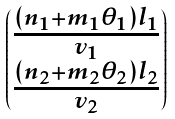Convert formula to latex. <formula><loc_0><loc_0><loc_500><loc_500>\begin{pmatrix} \frac { ( n _ { 1 } + m _ { 1 } \theta _ { 1 } ) l _ { 1 } } { v _ { 1 } } \\ \frac { ( n _ { 2 } + m _ { 2 } \theta _ { 2 } ) l _ { 2 } } { v _ { 2 } } \end{pmatrix}</formula> 